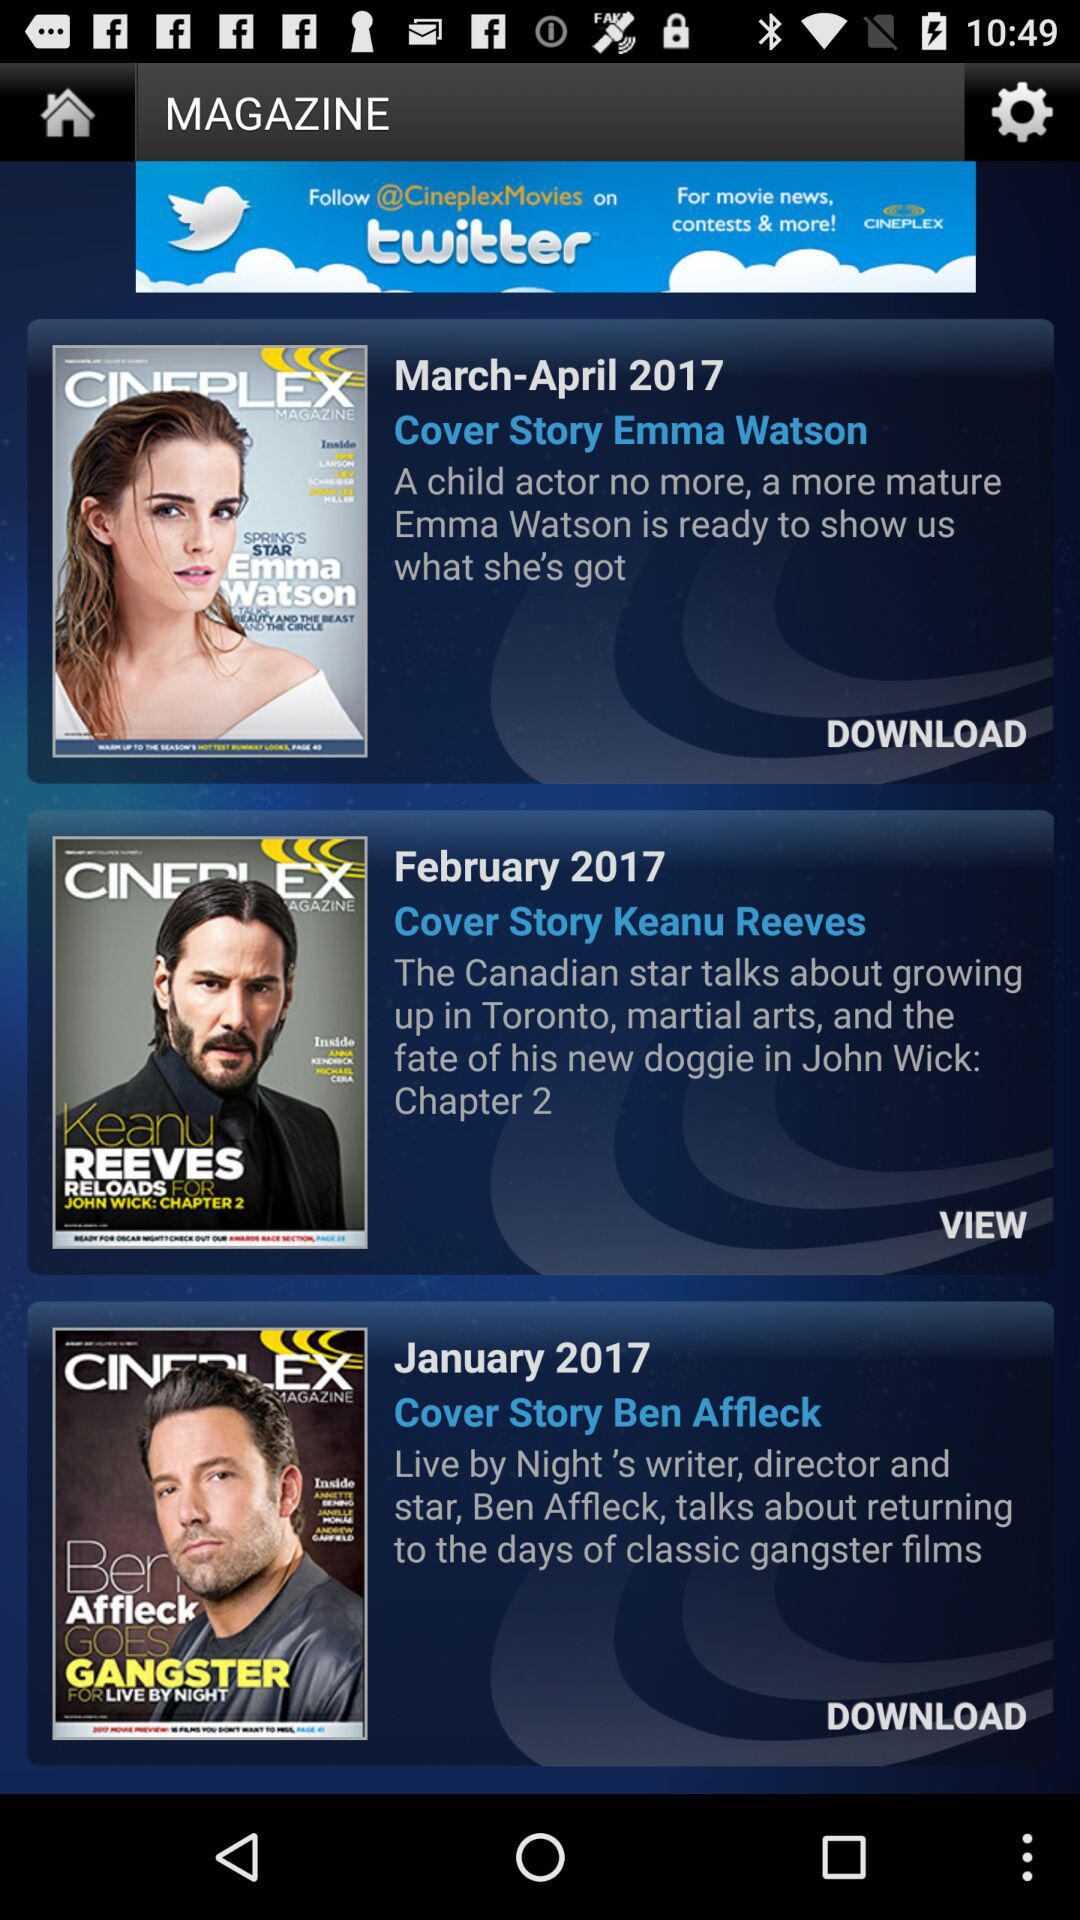When was the "Cover Story Ben Affleck" posted? It was posted in January 2017. 